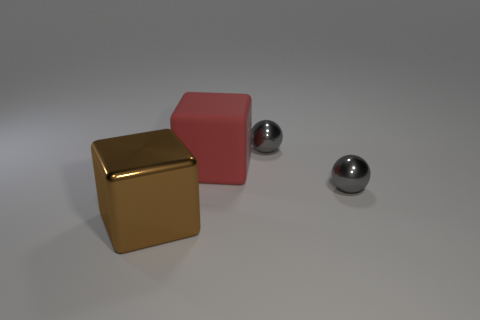There is a large brown object that is the same shape as the red rubber thing; what is it made of?
Make the answer very short. Metal. What is the color of the metal cube that is the same size as the matte block?
Ensure brevity in your answer.  Brown. Are there an equal number of rubber cubes in front of the red matte block and brown shiny cubes?
Your answer should be very brief. No. There is a block in front of the large thing that is right of the metallic cube; what is its color?
Make the answer very short. Brown. There is a metal ball that is behind the sphere that is in front of the big red matte block; how big is it?
Your response must be concise. Small. How many other objects are the same size as the brown metal block?
Provide a succinct answer. 1. The big object that is behind the gray sphere that is in front of the big red matte object behind the big brown thing is what color?
Keep it short and to the point. Red. How many other objects are the same shape as the brown object?
Your answer should be compact. 1. What shape is the big thing that is in front of the big rubber object?
Offer a very short reply. Cube. There is a sphere that is in front of the large red rubber block; is there a brown metallic cube that is right of it?
Keep it short and to the point. No. 